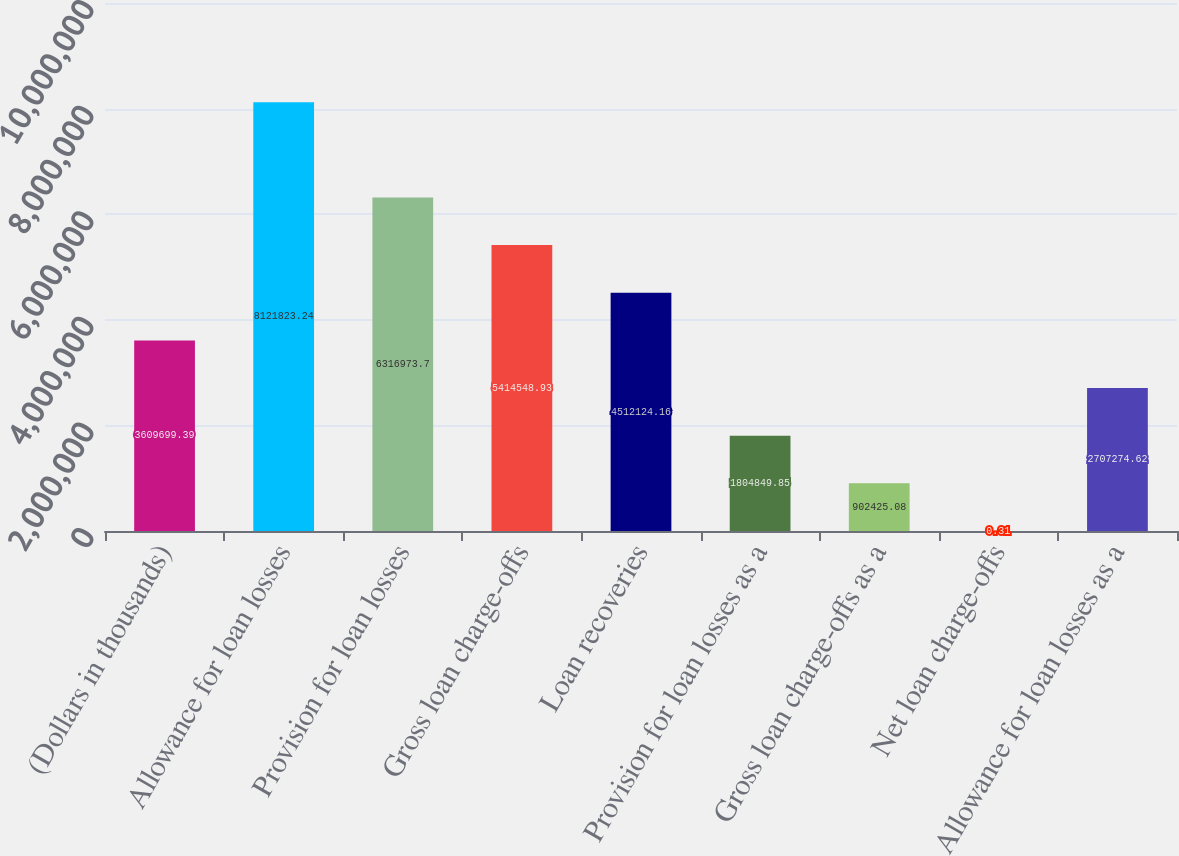<chart> <loc_0><loc_0><loc_500><loc_500><bar_chart><fcel>(Dollars in thousands)<fcel>Allowance for loan losses<fcel>Provision for loan losses<fcel>Gross loan charge-offs<fcel>Loan recoveries<fcel>Provision for loan losses as a<fcel>Gross loan charge-offs as a<fcel>Net loan charge-offs<fcel>Allowance for loan losses as a<nl><fcel>3.6097e+06<fcel>8.12182e+06<fcel>6.31697e+06<fcel>5.41455e+06<fcel>4.51212e+06<fcel>1.80485e+06<fcel>902425<fcel>0.31<fcel>2.70727e+06<nl></chart> 